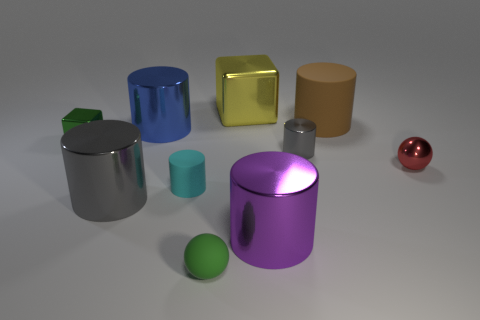Subtract all blue blocks. How many gray cylinders are left? 2 Subtract all blue shiny cylinders. How many cylinders are left? 5 Subtract all cyan cylinders. How many cylinders are left? 5 Subtract 4 cylinders. How many cylinders are left? 2 Add 6 big cyan rubber cylinders. How many big cyan rubber cylinders exist? 6 Subtract 0 brown cubes. How many objects are left? 10 Subtract all spheres. How many objects are left? 8 Subtract all green cylinders. Subtract all brown blocks. How many cylinders are left? 6 Subtract all blue metal cylinders. Subtract all big blue cylinders. How many objects are left? 8 Add 5 tiny red metallic objects. How many tiny red metallic objects are left? 6 